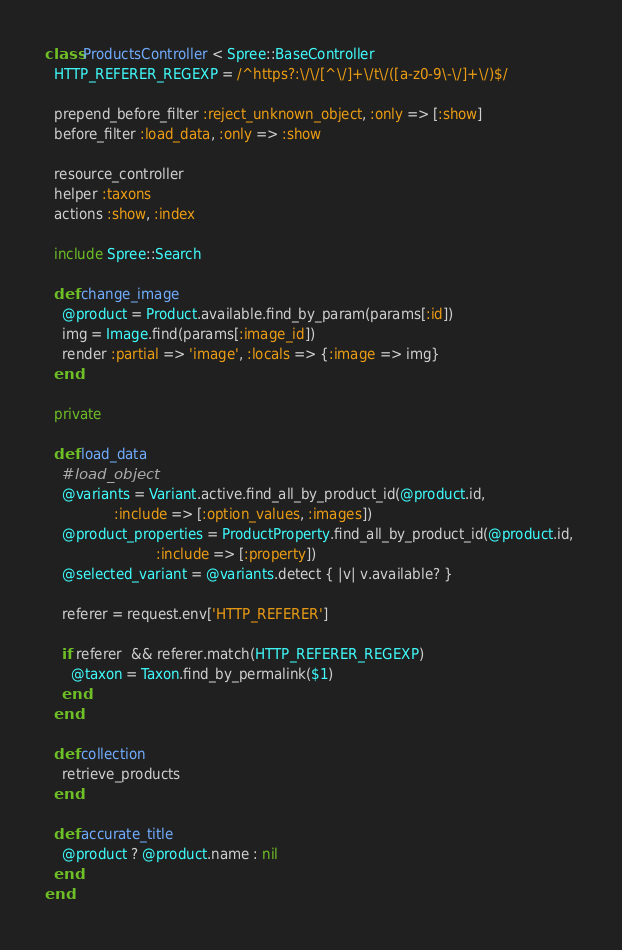Convert code to text. <code><loc_0><loc_0><loc_500><loc_500><_Ruby_>class ProductsController < Spree::BaseController
  HTTP_REFERER_REGEXP = /^https?:\/\/[^\/]+\/t\/([a-z0-9\-\/]+\/)$/

  prepend_before_filter :reject_unknown_object, :only => [:show]
  before_filter :load_data, :only => :show

  resource_controller
  helper :taxons
  actions :show, :index

  include Spree::Search

  def change_image
    @product = Product.available.find_by_param(params[:id])
    img = Image.find(params[:image_id])
    render :partial => 'image', :locals => {:image => img}
  end

  private

  def load_data
    #load_object  
    @variants = Variant.active.find_all_by_product_id(@product.id, 
                :include => [:option_values, :images])
    @product_properties = ProductProperty.find_all_by_product_id(@product.id, 
                          :include => [:property])
    @selected_variant = @variants.detect { |v| v.available? }

    referer = request.env['HTTP_REFERER']

    if referer  && referer.match(HTTP_REFERER_REGEXP)
      @taxon = Taxon.find_by_permalink($1)
    end
  end

  def collection
    retrieve_products
  end
  
  def accurate_title
    @product ? @product.name : nil
  end
end
</code> 